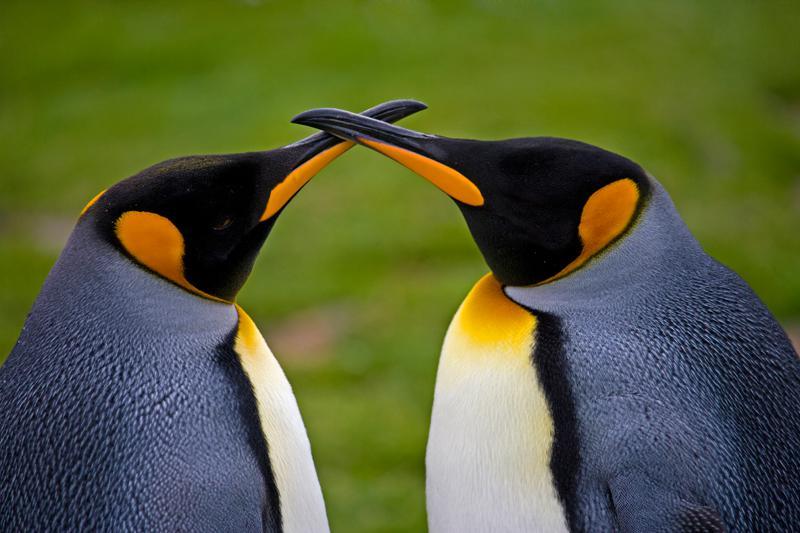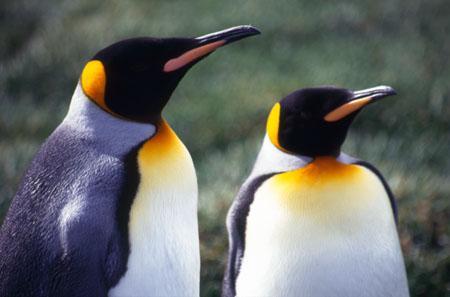The first image is the image on the left, the second image is the image on the right. For the images displayed, is the sentence "In total, there are no more than five penguins pictured." factually correct? Answer yes or no. Yes. 